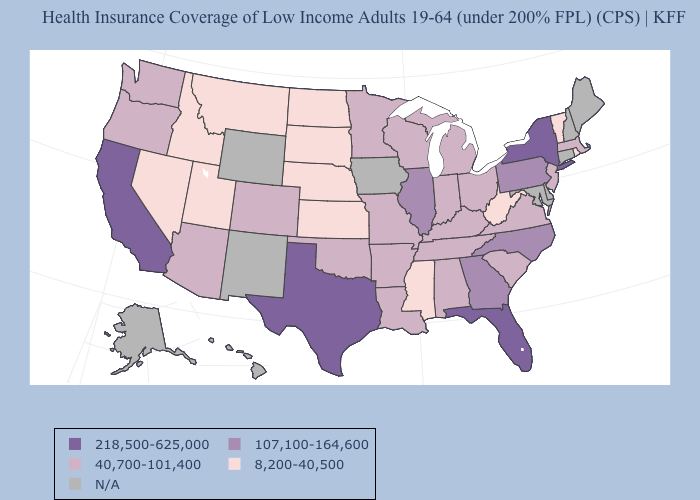Among the states that border Mississippi , which have the highest value?
Concise answer only. Alabama, Arkansas, Louisiana, Tennessee. What is the value of Arkansas?
Keep it brief. 40,700-101,400. Name the states that have a value in the range 8,200-40,500?
Quick response, please. Idaho, Kansas, Mississippi, Montana, Nebraska, Nevada, North Dakota, Rhode Island, South Dakota, Utah, Vermont, West Virginia. Does West Virginia have the highest value in the USA?
Keep it brief. No. Name the states that have a value in the range N/A?
Keep it brief. Alaska, Connecticut, Delaware, Hawaii, Iowa, Maine, Maryland, New Hampshire, New Mexico, Wyoming. Name the states that have a value in the range N/A?
Keep it brief. Alaska, Connecticut, Delaware, Hawaii, Iowa, Maine, Maryland, New Hampshire, New Mexico, Wyoming. Does Arizona have the lowest value in the West?
Be succinct. No. What is the value of Washington?
Write a very short answer. 40,700-101,400. Among the states that border Utah , does Idaho have the highest value?
Be succinct. No. Name the states that have a value in the range N/A?
Keep it brief. Alaska, Connecticut, Delaware, Hawaii, Iowa, Maine, Maryland, New Hampshire, New Mexico, Wyoming. Does the first symbol in the legend represent the smallest category?
Short answer required. No. Name the states that have a value in the range 218,500-625,000?
Write a very short answer. California, Florida, New York, Texas. What is the value of Minnesota?
Keep it brief. 40,700-101,400. 